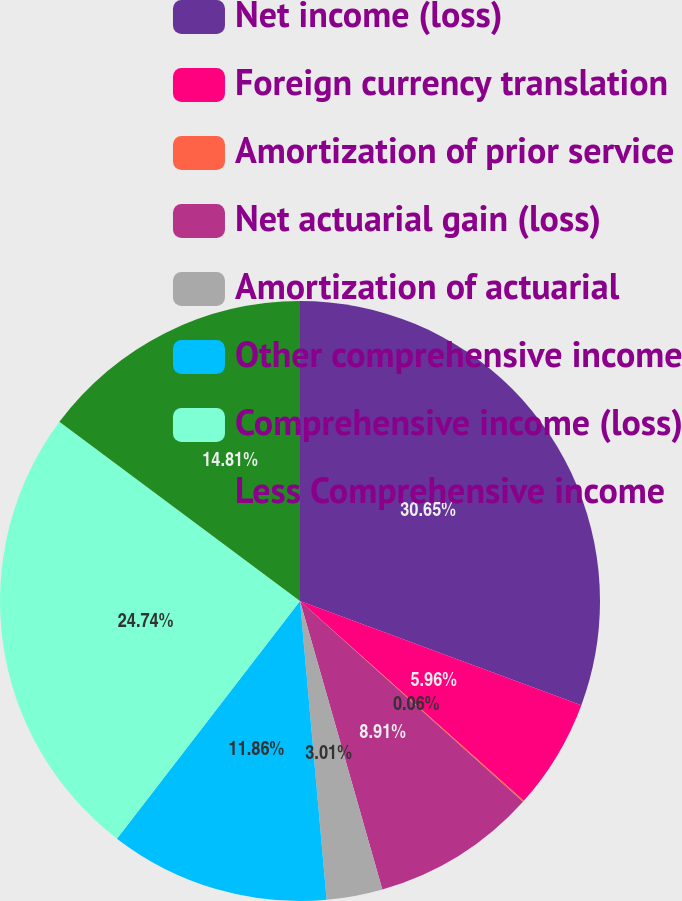<chart> <loc_0><loc_0><loc_500><loc_500><pie_chart><fcel>Net income (loss)<fcel>Foreign currency translation<fcel>Amortization of prior service<fcel>Net actuarial gain (loss)<fcel>Amortization of actuarial<fcel>Other comprehensive income<fcel>Comprehensive income (loss)<fcel>Less Comprehensive income<nl><fcel>30.64%<fcel>5.96%<fcel>0.06%<fcel>8.91%<fcel>3.01%<fcel>11.86%<fcel>24.74%<fcel>14.81%<nl></chart> 